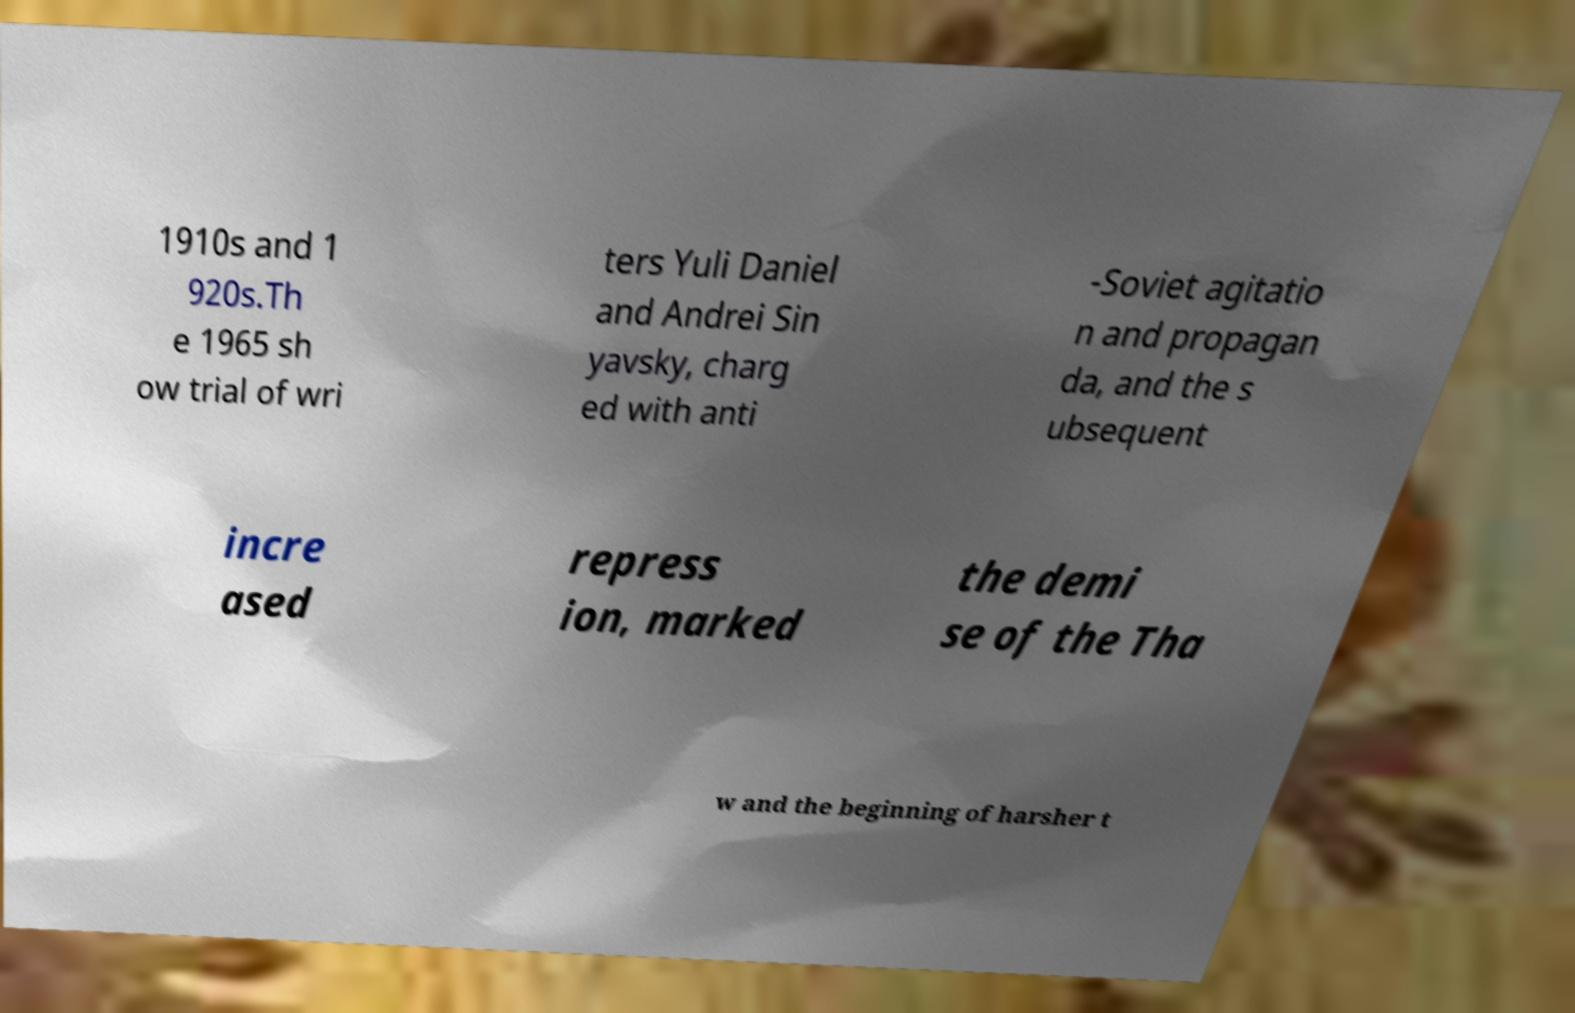What messages or text are displayed in this image? I need them in a readable, typed format. 1910s and 1 920s.Th e 1965 sh ow trial of wri ters Yuli Daniel and Andrei Sin yavsky, charg ed with anti -Soviet agitatio n and propagan da, and the s ubsequent incre ased repress ion, marked the demi se of the Tha w and the beginning of harsher t 